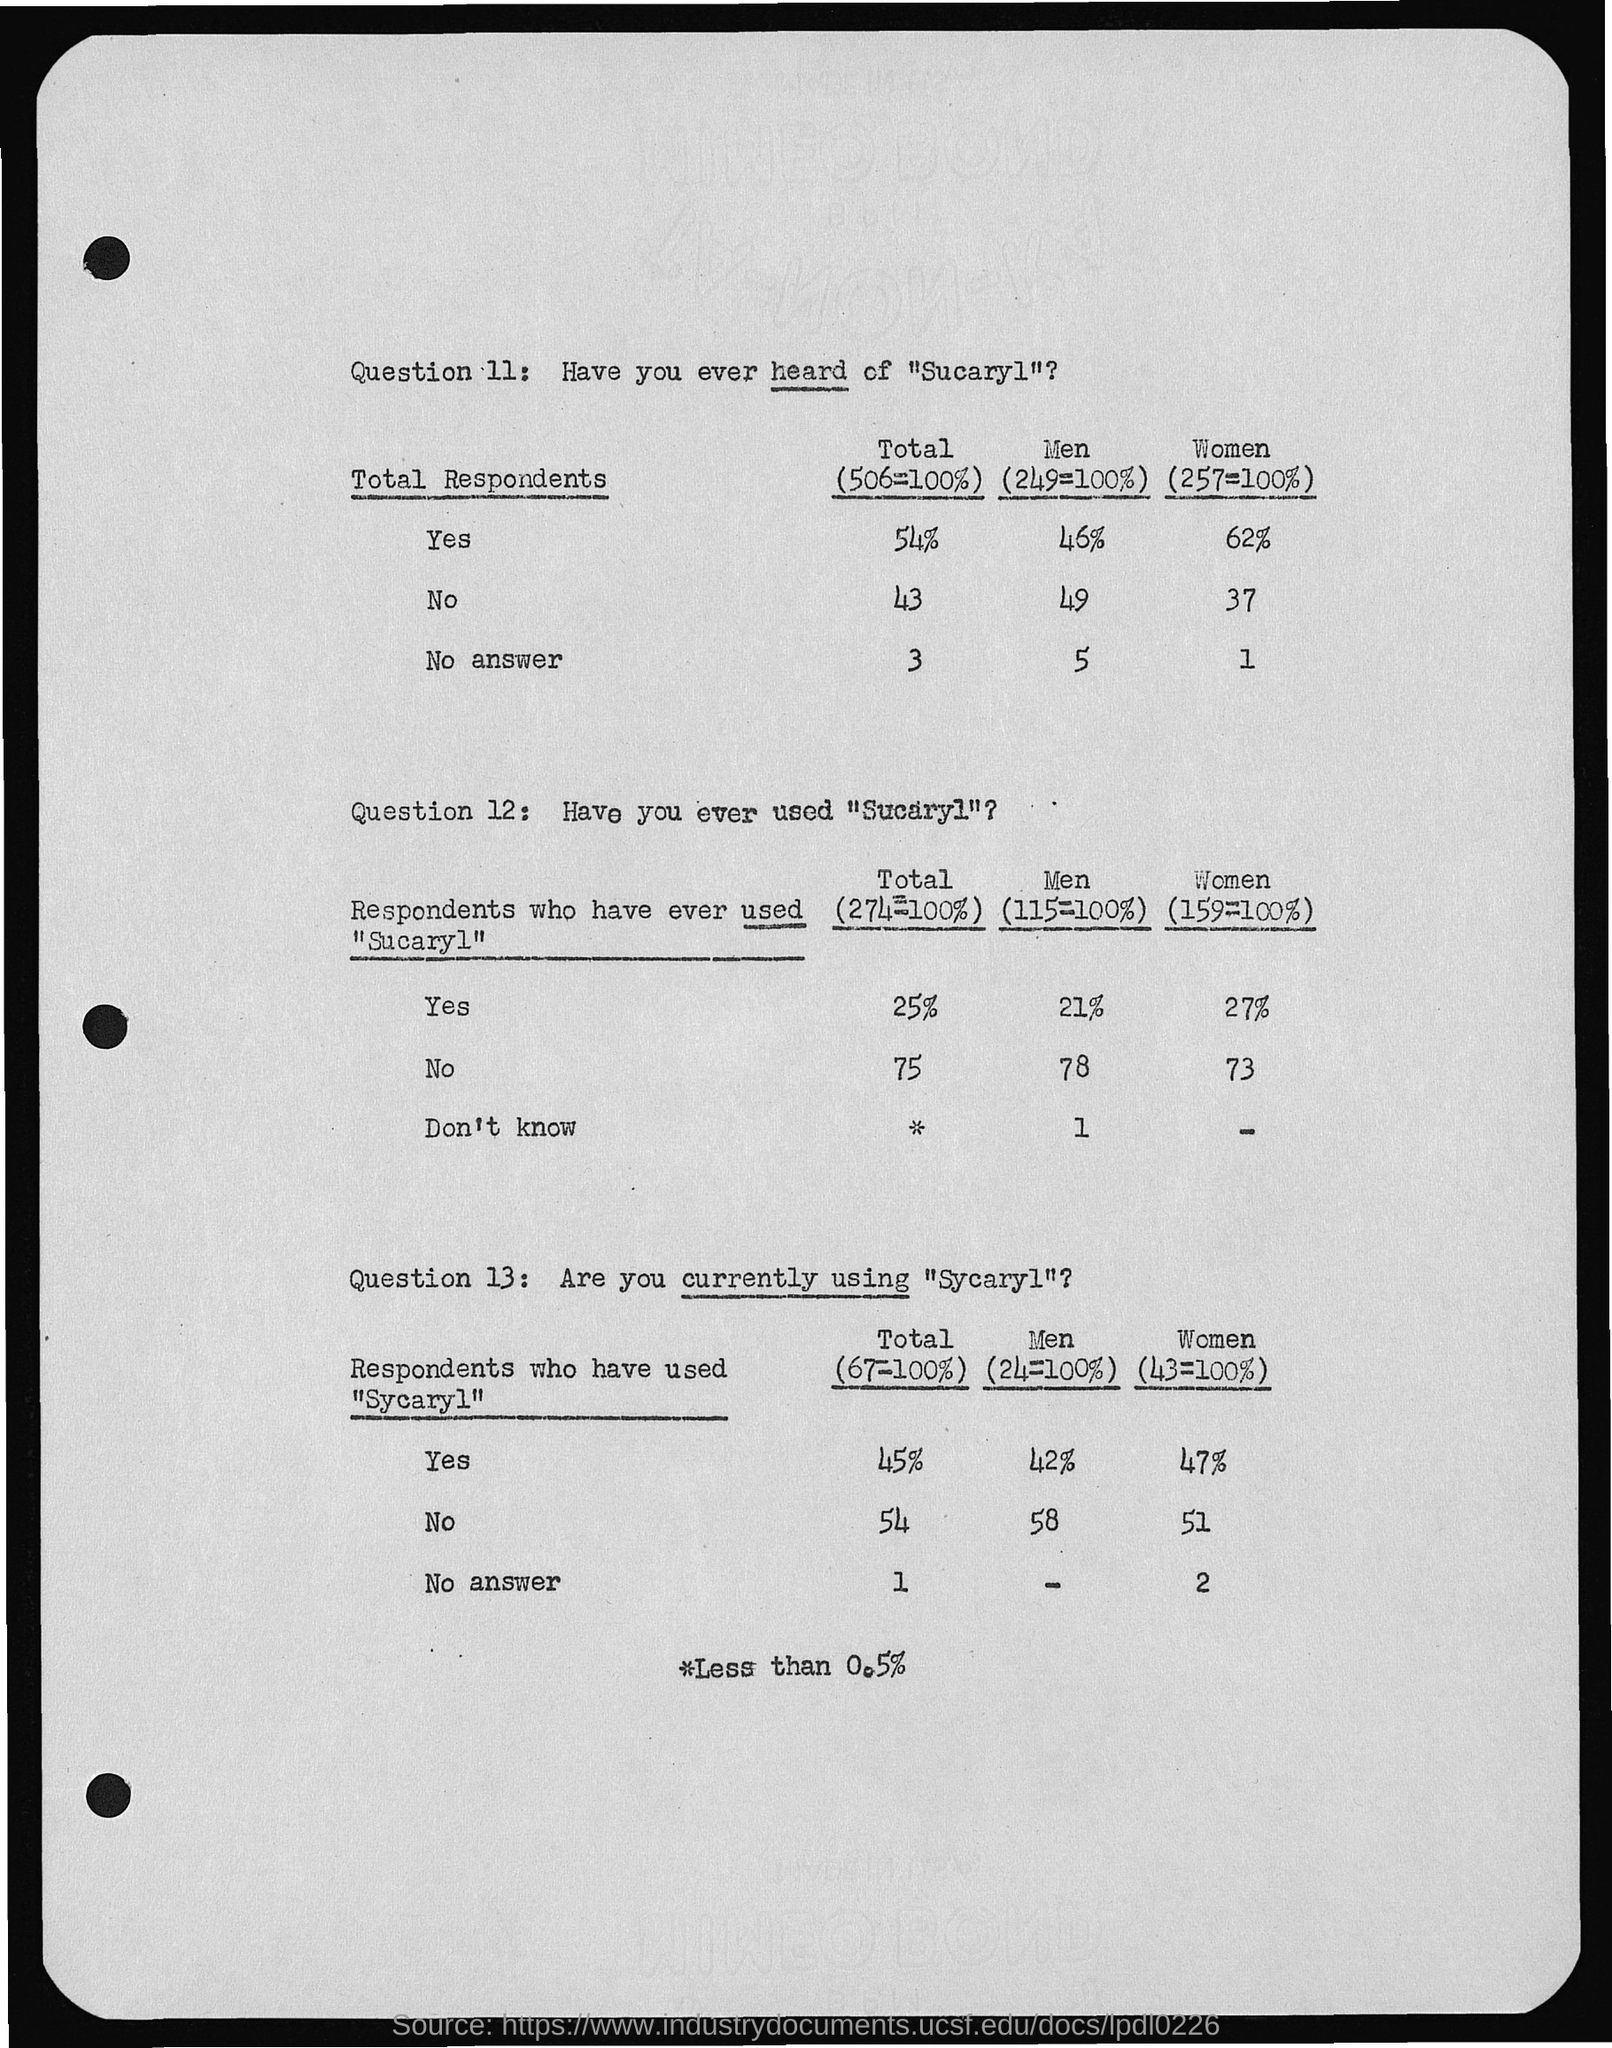What are the Total "who have heard of Sucaryl" who said yes?
Provide a short and direct response. 54%. What are the Men "who have heard of Sucaryl" who said yes?
Provide a short and direct response. 46%. What are the Women "who have heard of Sucaryl" who said yes?
Give a very brief answer. 62. What are the Total "who have heard of Sucaryl" who said No?
Your answer should be compact. 43. What are the Men "who have heard of Sucaryl" who said no?
Give a very brief answer. 49. What are the Women "who have heard of Sucaryl" who said yno?
Your answer should be compact. 37. What are the Women "who have used Sucaryl" who said yes?
Keep it short and to the point. 27%. What are the men "who have used Sucaryl" who said yes?
Ensure brevity in your answer.  21. What are the Total "who have used Sucaryl" who said yes?
Provide a short and direct response. 25%. What are the Women "who have used Sucaryl" who said no?
Offer a very short reply. 73. 